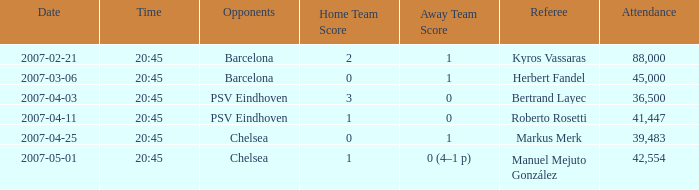WHAT WAS THE SCORE OF THE GAME WITH A 2007-03-06, 20:45 KICKOFF? 0–1. 